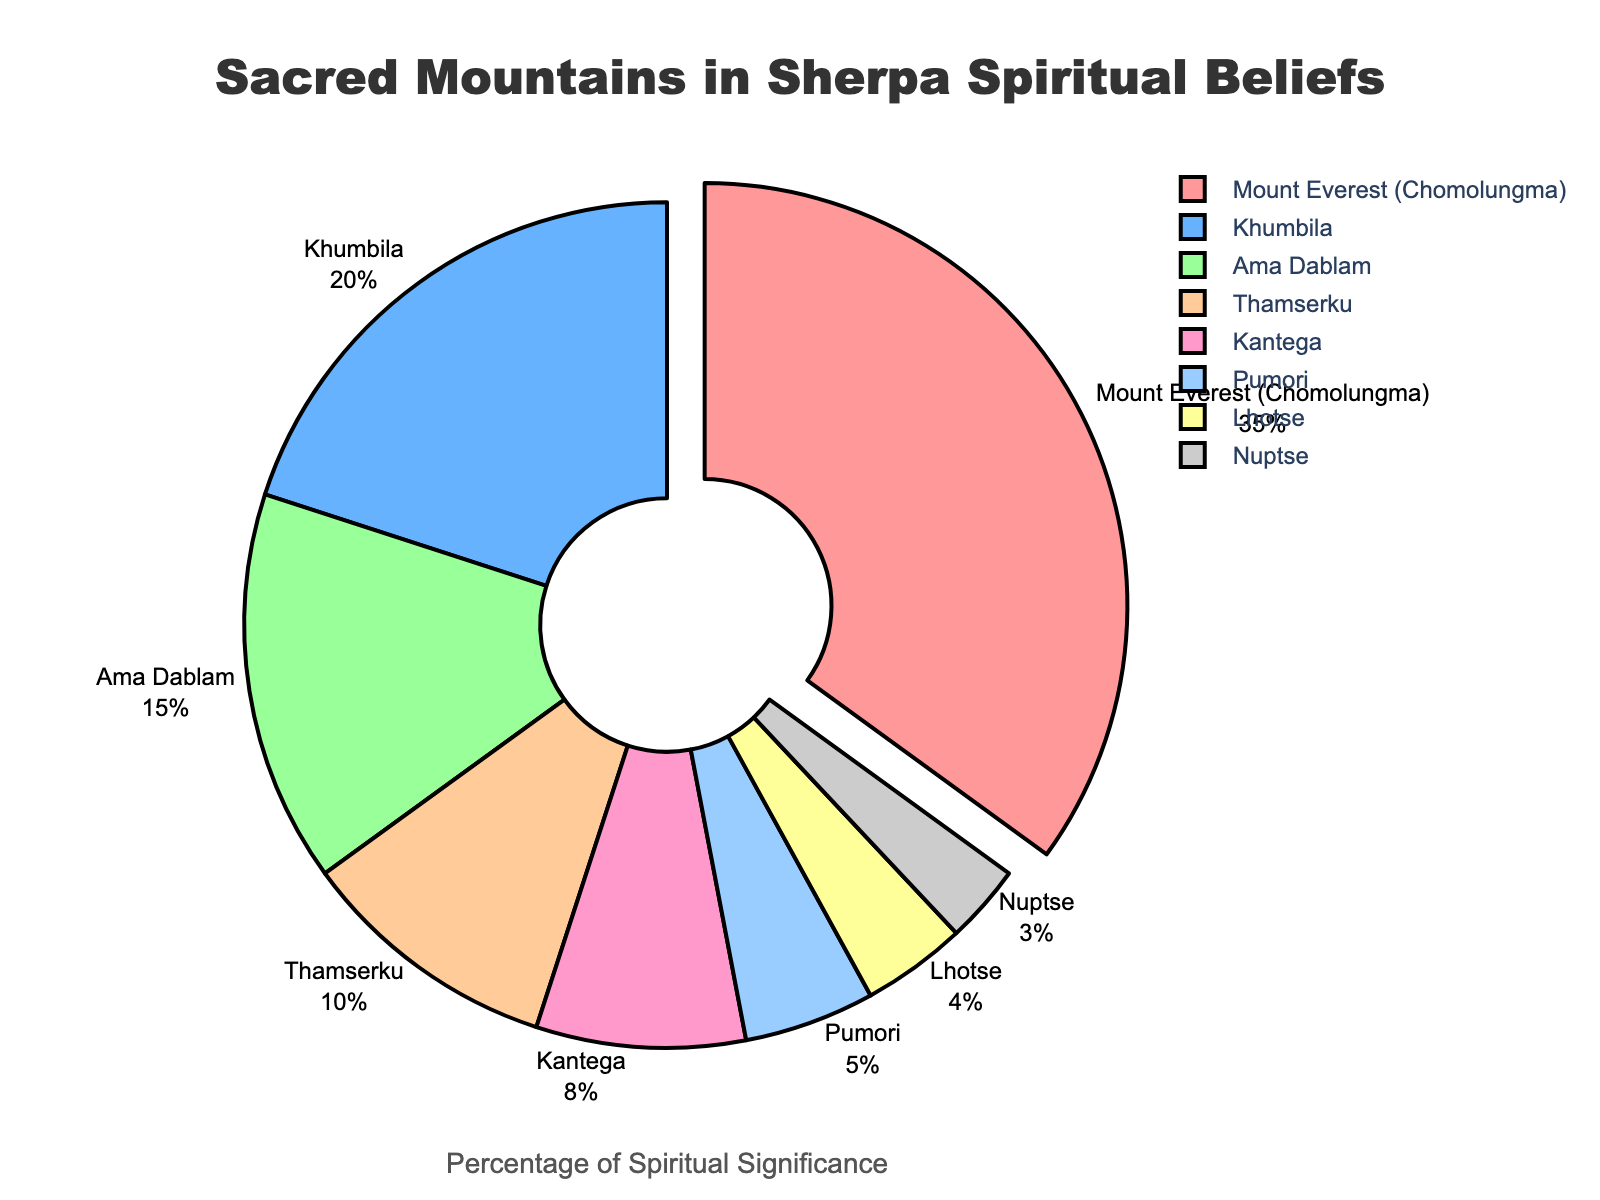What is the percentage of significance for Mount Everest (Chomolungma) in the pie chart? The label for Mount Everest (Chomolungma) shows a percentage of 35%.
Answer: 35% Which mountain has the second highest percentage of spiritual significance? The mountain with the second highest percentage, after Mount Everest (35%), is Khumbila, which has 20%.
Answer: Khumbila How much more significant is Ama Dablam compared to Thamserku? Ama Dablam has a significance of 15%, and Thamserku has 10%. The difference is 15% - 10% = 5%.
Answer: 5% If we combine the significance of Kantega and Pumori, what is the total percentage? Kantega has a significance of 8%, and Pumori has 5%. Adding these together, 8% + 5% = 13%.
Answer: 13% Which mountain has the least spiritual significance in Sherpa beliefs based on the pie chart? The label for the lowest percentage is Nuptse, which has 3%.
Answer: Nuptse What is the combined significance of the mountains with the top three percentages? The top three mountains by percentage are Mount Everest (35%), Khumbila (20%), and Ama Dablam (15%). Summing these, 35% + 20% + 15% = 70%.
Answer: 70% Is Thamserku more or less significant than Kantega? By how much? Thamserku has a significance of 10%, while Kantega has 8%. Thamserku is 2% more significant than Kantega.
Answer: 2% more Which mountains are assigned a blue shade in the pie chart? The pie chart labels with blue shades include Khumbila (second sector) and Kantega (fifth sector).
Answer: Khumbila and Kantega Comparing Khumbila and Lhotse, how many times greater is Khumbila's percentage? Khumbila has a percentage of 20%, and Lhotse has 4%. Dividing these, 20% ÷ 4% = 5 times.
Answer: 5 times What is the total percentage for the mountains with a significance less than 10%? Adding the percentages of Thamserku (10%), Kantega (8%), Pumori (5%), Lhotse (4%), and Nuptse (3%): 10% + 8% + 5% + 4% + 3% = 30%. However, the question asks for those less than 10%, so 8% + 5% + 4% + 3% = 20%.
Answer: 20% 